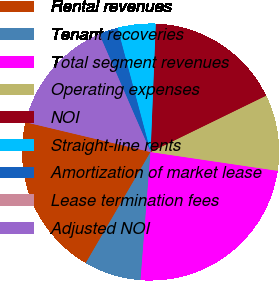<chart> <loc_0><loc_0><loc_500><loc_500><pie_chart><fcel>Rental revenues<fcel>Tenant recoveries<fcel>Total segment revenues<fcel>Operating expenses<fcel>NOI<fcel>Straight-line rents<fcel>Amortization of market lease<fcel>Lease termination fees<fcel>Adjusted NOI<nl><fcel>20.32%<fcel>7.17%<fcel>23.9%<fcel>9.56%<fcel>17.13%<fcel>4.78%<fcel>2.39%<fcel>0.0%<fcel>14.74%<nl></chart> 